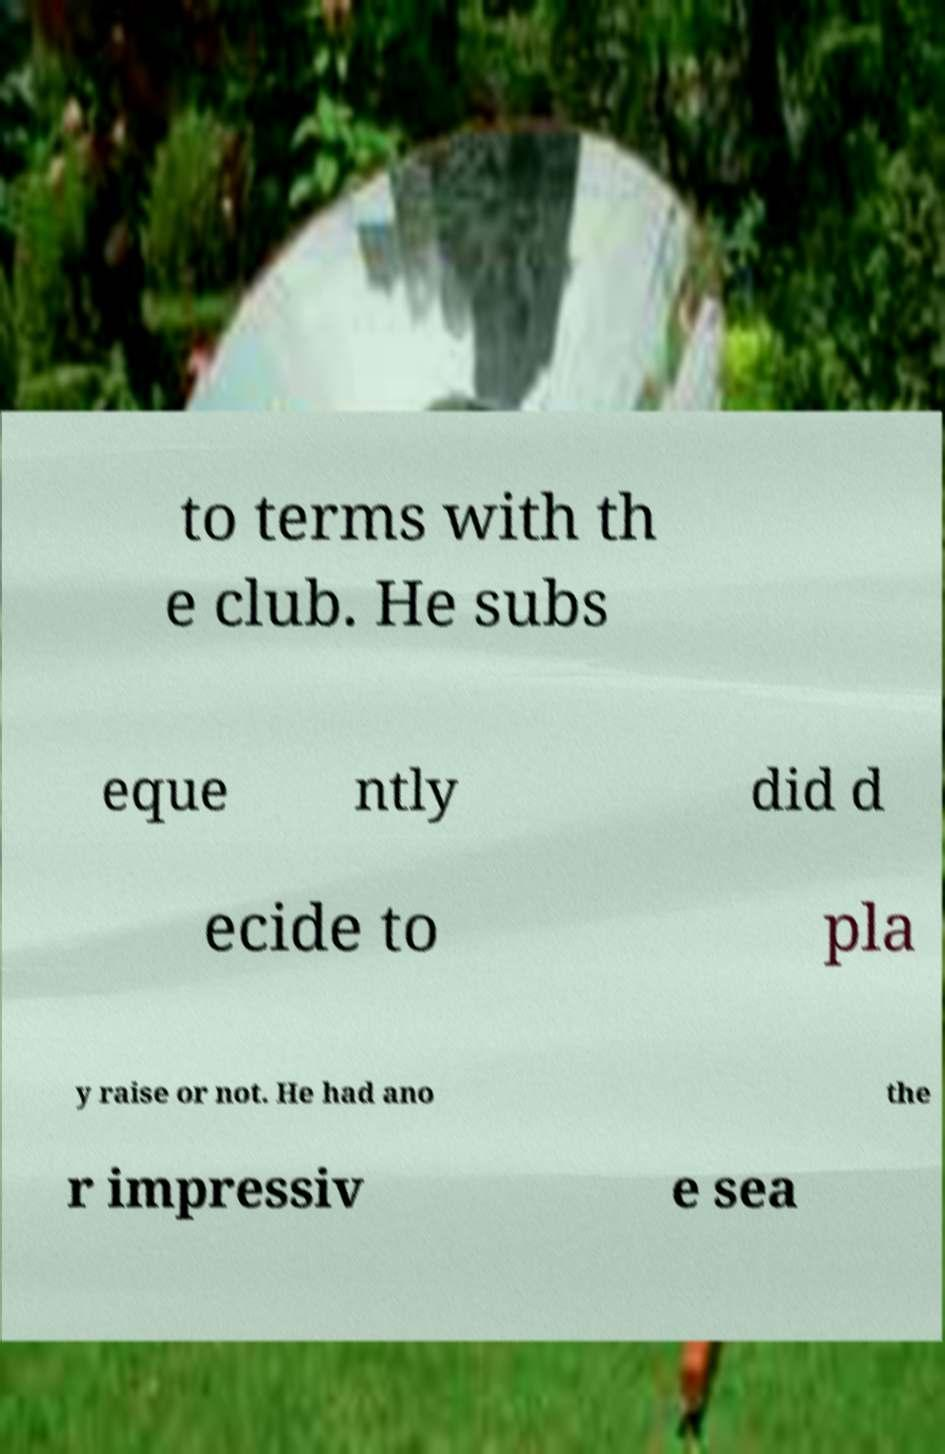Could you extract and type out the text from this image? to terms with th e club. He subs eque ntly did d ecide to pla y raise or not. He had ano the r impressiv e sea 